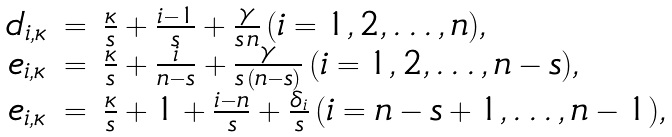<formula> <loc_0><loc_0><loc_500><loc_500>\begin{array} { r c l } d _ { i , \kappa } & = & \frac { \kappa } { s } + \frac { i - 1 } { s } + \frac { \gamma } { s \, n } \, ( i = 1 , 2 , \dots , n ) , \\ e _ { i , \kappa } & = & \frac { \kappa } { s } + \frac { i } { n - s } + \frac { \gamma } { s \, ( n - s ) } \, ( i = 1 , 2 , \dots , n - s ) , \\ e _ { i , \kappa } & = & \frac { \kappa } { s } + 1 + \frac { i - n } { s } + \frac { \delta _ { i } } { s } \, ( i = n - s + 1 , \dots , n - 1 ) , \end{array}</formula> 